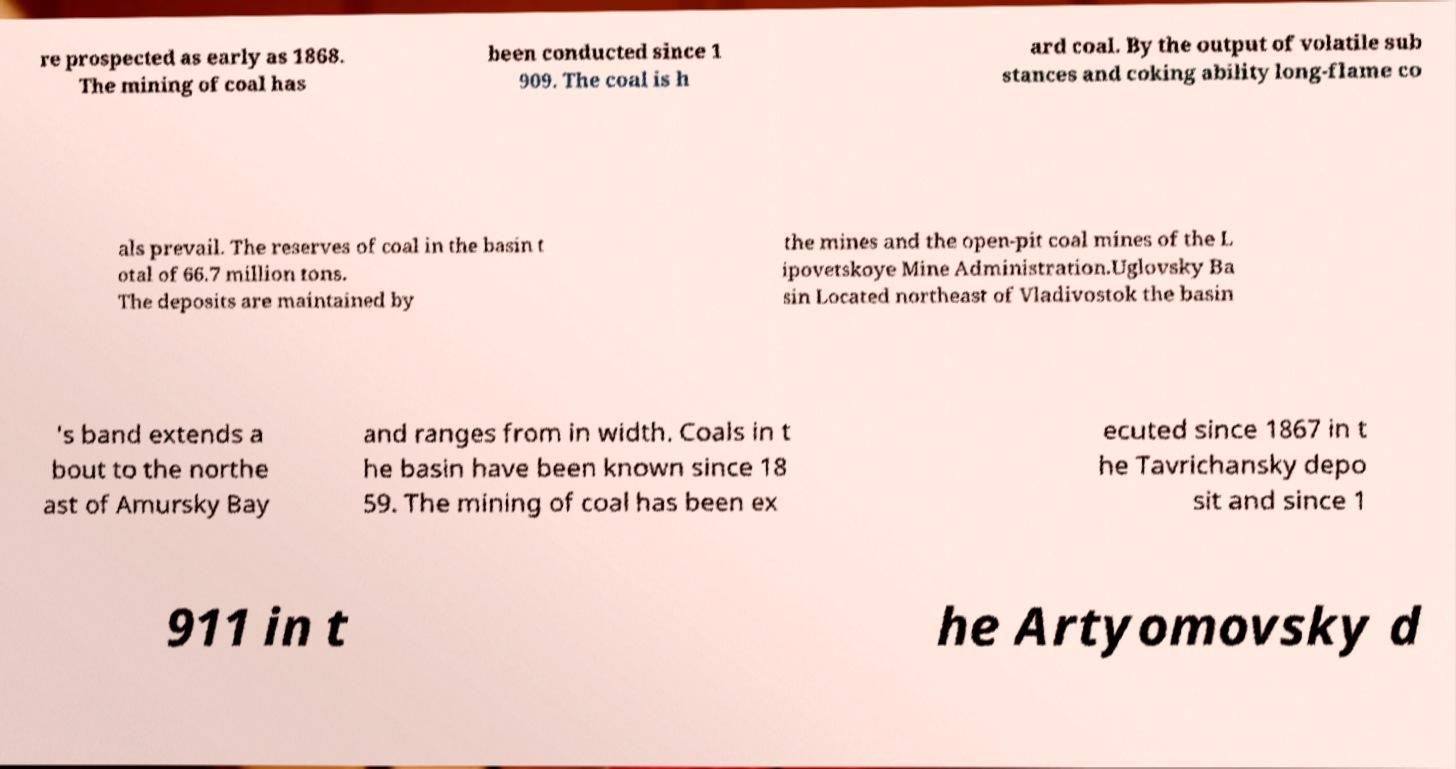There's text embedded in this image that I need extracted. Can you transcribe it verbatim? re prospected as early as 1868. The mining of coal has been conducted since 1 909. The coal is h ard coal. By the output of volatile sub stances and coking ability long-flame co als prevail. The reserves of coal in the basin t otal of 66.7 million tons. The deposits are maintained by the mines and the open-pit coal mines of the L ipovetskoye Mine Administration.Uglovsky Ba sin Located northeast of Vladivostok the basin 's band extends a bout to the northe ast of Amursky Bay and ranges from in width. Coals in t he basin have been known since 18 59. The mining of coal has been ex ecuted since 1867 in t he Tavrichansky depo sit and since 1 911 in t he Artyomovsky d 